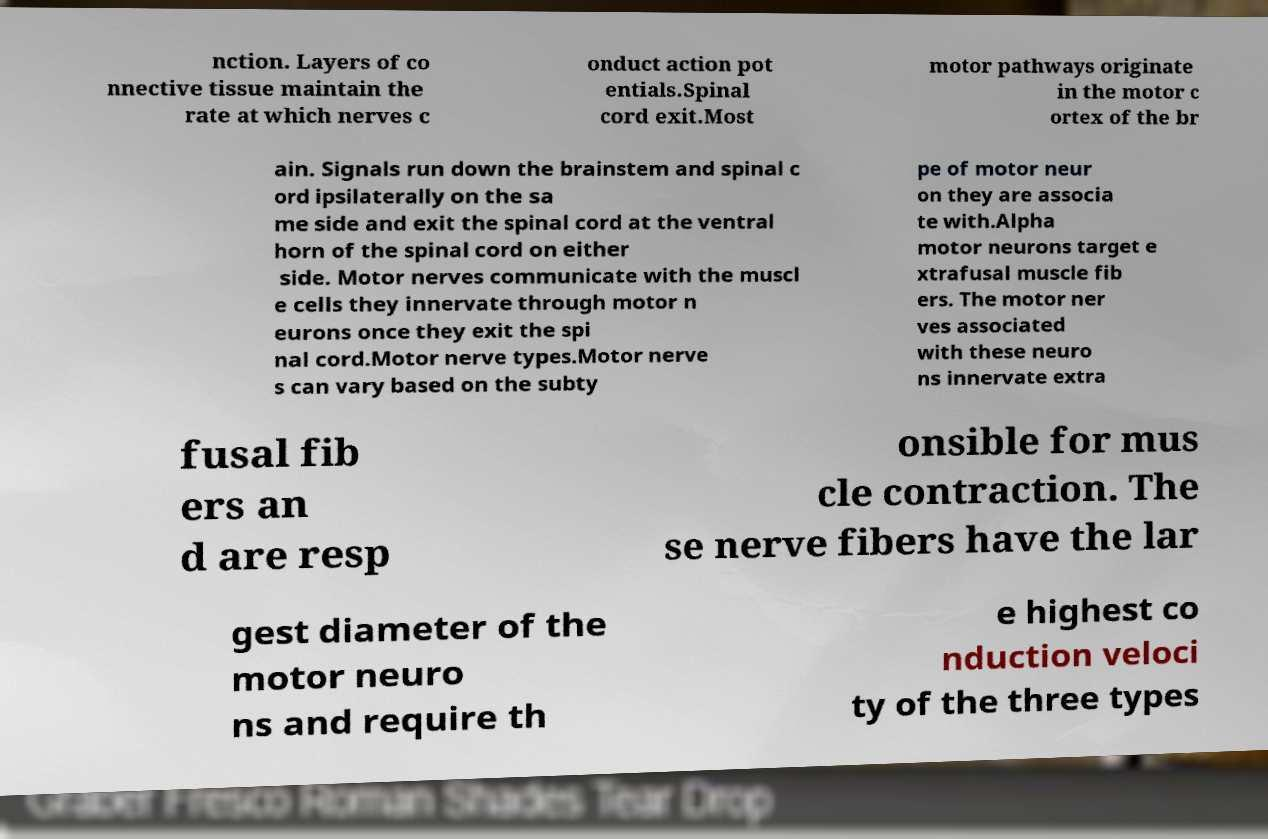Can you accurately transcribe the text from the provided image for me? nction. Layers of co nnective tissue maintain the rate at which nerves c onduct action pot entials.Spinal cord exit.Most motor pathways originate in the motor c ortex of the br ain. Signals run down the brainstem and spinal c ord ipsilaterally on the sa me side and exit the spinal cord at the ventral horn of the spinal cord on either side. Motor nerves communicate with the muscl e cells they innervate through motor n eurons once they exit the spi nal cord.Motor nerve types.Motor nerve s can vary based on the subty pe of motor neur on they are associa te with.Alpha motor neurons target e xtrafusal muscle fib ers. The motor ner ves associated with these neuro ns innervate extra fusal fib ers an d are resp onsible for mus cle contraction. The se nerve fibers have the lar gest diameter of the motor neuro ns and require th e highest co nduction veloci ty of the three types 